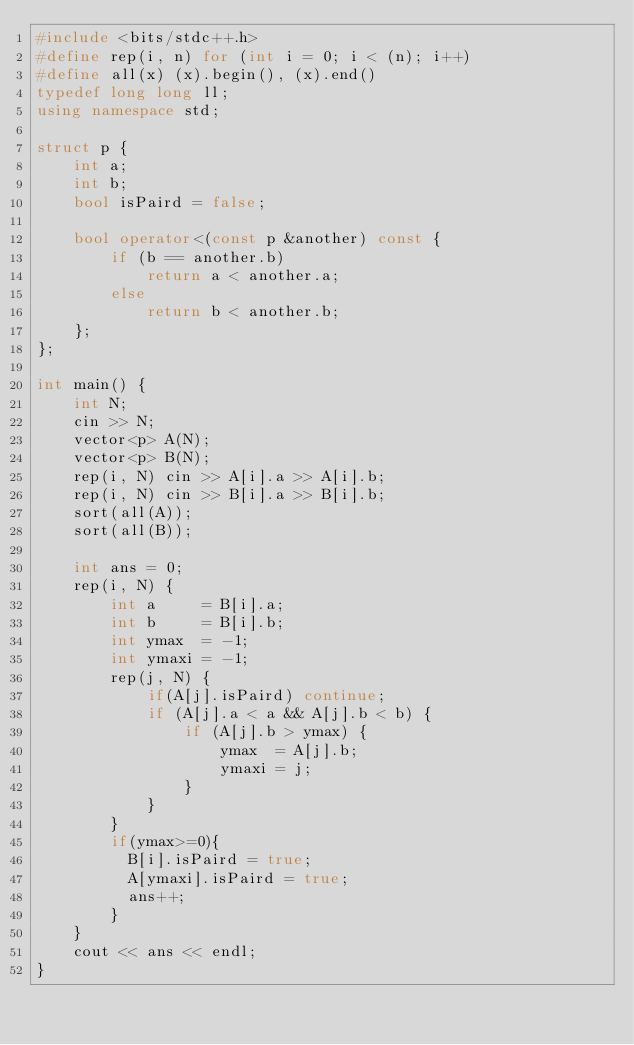<code> <loc_0><loc_0><loc_500><loc_500><_C++_>#include <bits/stdc++.h>
#define rep(i, n) for (int i = 0; i < (n); i++)
#define all(x) (x).begin(), (x).end()
typedef long long ll;
using namespace std;

struct p {
    int a;
    int b;
    bool isPaird = false;

    bool operator<(const p &another) const {
        if (b == another.b)
            return a < another.a;
        else
            return b < another.b;
    };
};

int main() {
    int N;
    cin >> N;
    vector<p> A(N);
    vector<p> B(N);
    rep(i, N) cin >> A[i].a >> A[i].b;
    rep(i, N) cin >> B[i].a >> B[i].b;
    sort(all(A));
    sort(all(B));

    int ans = 0;
    rep(i, N) {
        int a     = B[i].a;
        int b     = B[i].b;
        int ymax  = -1;
        int ymaxi = -1;
        rep(j, N) {
            if(A[j].isPaird) continue;
            if (A[j].a < a && A[j].b < b) {
                if (A[j].b > ymax) {
                    ymax  = A[j].b;
                    ymaxi = j;
                }
            }
        }
        if(ymax>=0){
          B[i].isPaird = true;
          A[ymaxi].isPaird = true;
          ans++;
        }
    }
    cout << ans << endl;
}</code> 